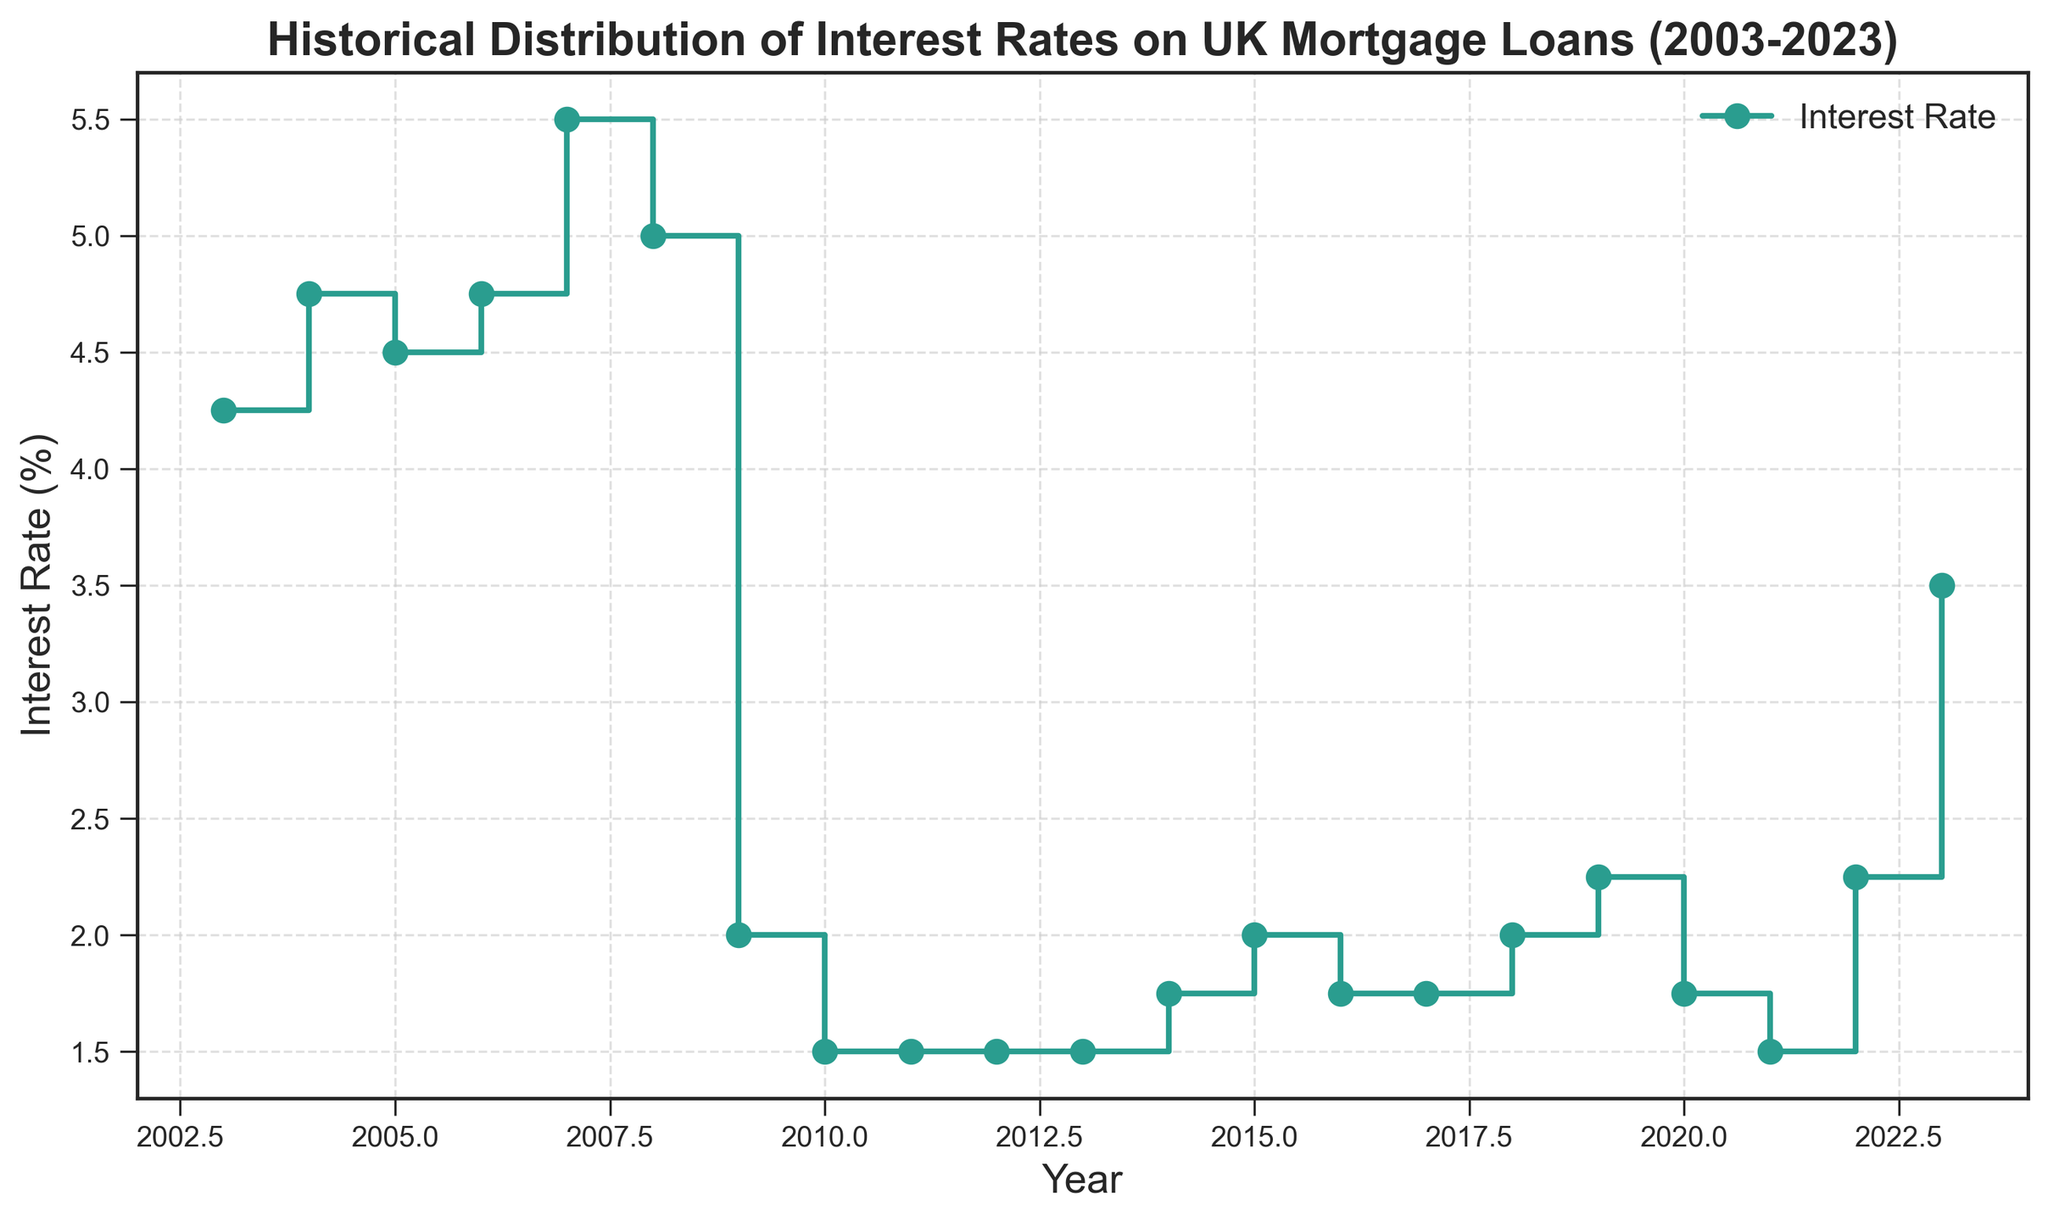What was the highest interest rate recorded in the last 20 years? To find the highest interest rate, look for the tallest step in the stairs plot or the highest y-value. The peak interest rate is recorded in 2007, which is 5.50%.
Answer: 5.50% Which year experienced the lowest interest rate, and what was it? Identify the shortest step in the stairs plot or the lowest y-value. The lowest interest rate is recorded in 2010, 2011, and 2012, where it is 1.50%.
Answer: 2010-2012, 1.50% How did the interest rates change from 2008 to 2009? Examine the plot between 2008 and 2009. The interest rate sharply dropped from 5.00% in 2008 to 2.00% in 2009.
Answer: Dropped from 5.00% to 2.00% What is the average interest rate over the 20-year period displayed? Sum all the interest rates given for each year and then divide by the number of years (21). \( \frac{4.25 + 4.75 + 4.50 + 4.75 + 5.50 + 5.00 + 2.00 + 1.50 + 1.50 + 1.50 + 1.50 + 1.75 + 2.00 + 1.75 + 1.75 + 2.00 + 2.25 + 1.75 + 1.50 + 2.25 + 3.50}{21} = \frac{54.25}{21} \approx 2.583\% \)
Answer: 2.58% Compare the interest rates between 2007 and 2014 and describe the significant changes. In 2007, the interest rate was 5.50%. By 2010, it fell significantly to 1.50%, remaining low until 2014 when it started to rise, reaching 1.75%. The significant change was the steep drop in 2008-2009 due to the financial crisis.
Answer: Sharp decline from 2007 to 2009 What was the trend of interest rates between 2015 and 2020? From 2015 to 2020, examine the plot to identify the pattern. It shows mild fluctuations, starting from 2.00% in 2015, dropping to 1.75%, and fluctuating around this value until it returns to 2.25% by 2020.
Answer: Fluctuating mild increase In which year did the interest rate increase after a period of stability, and by how much? Look for a flat section followed by an increase. After steady rates of 1.50% from 2009-2013, interest increased to 1.75% in 2014.
Answer: 2014, by 0.25% What significant changes in the interest rate happened right after 2020? The interest rate in 2020 was 1.75%. It dropped to 1.50% in 2021 but sharply increased to 2.25% in 2022 and then 3.50% in 2023.
Answer: Sharp increase from 1.50% to 3.50% Which decade faced more fluctuation in interest rates, the 2000s or the 2010s? Compare the plot lines’ steepness and frequency of changes between these two periods. The 2000s had rates ranging from 4.25% to 5.50% with less fluctuation, whereas the 2010s had rates between 1.50% and 2.25% with smaller but frequent changes.
Answer: 2010s had more fluctuations 